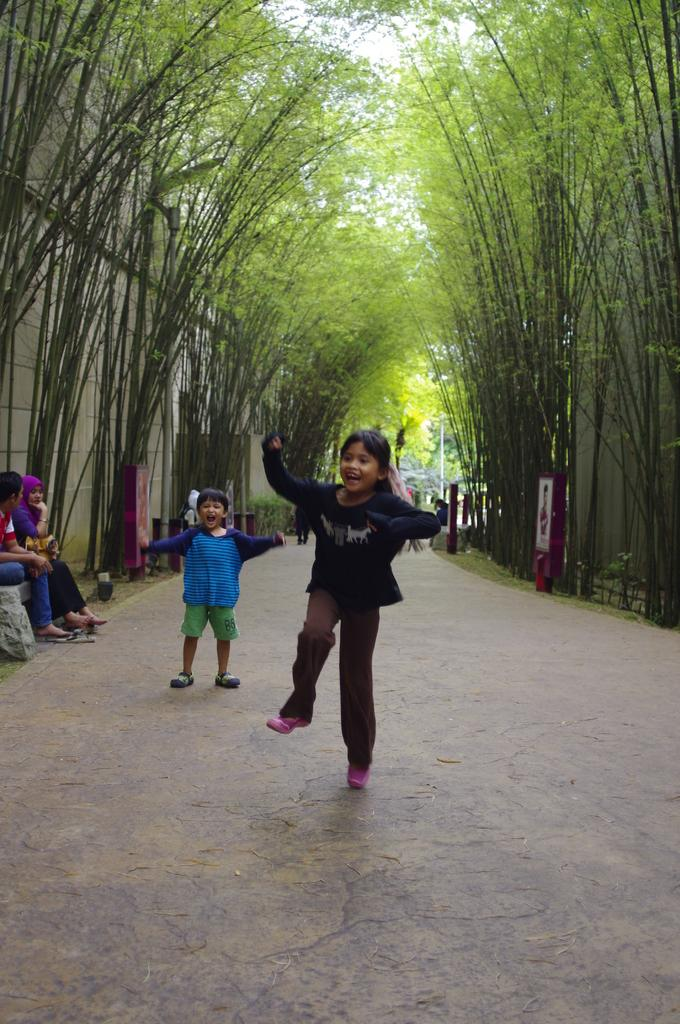How many kids are present in the image? There are two kids standing in the image. What else can be seen in the image besides the kids? There is a group of people and trees in the image. What type of pathway is visible in the image? There is a walkway in the image. What is visible in the background of the image? The sky is visible in the image. What color is the balloon that the kids are holding in the image? There is no balloon present in the image. What is the desire of the group of people in the image? The image does not provide information about the desires of the group of people. 